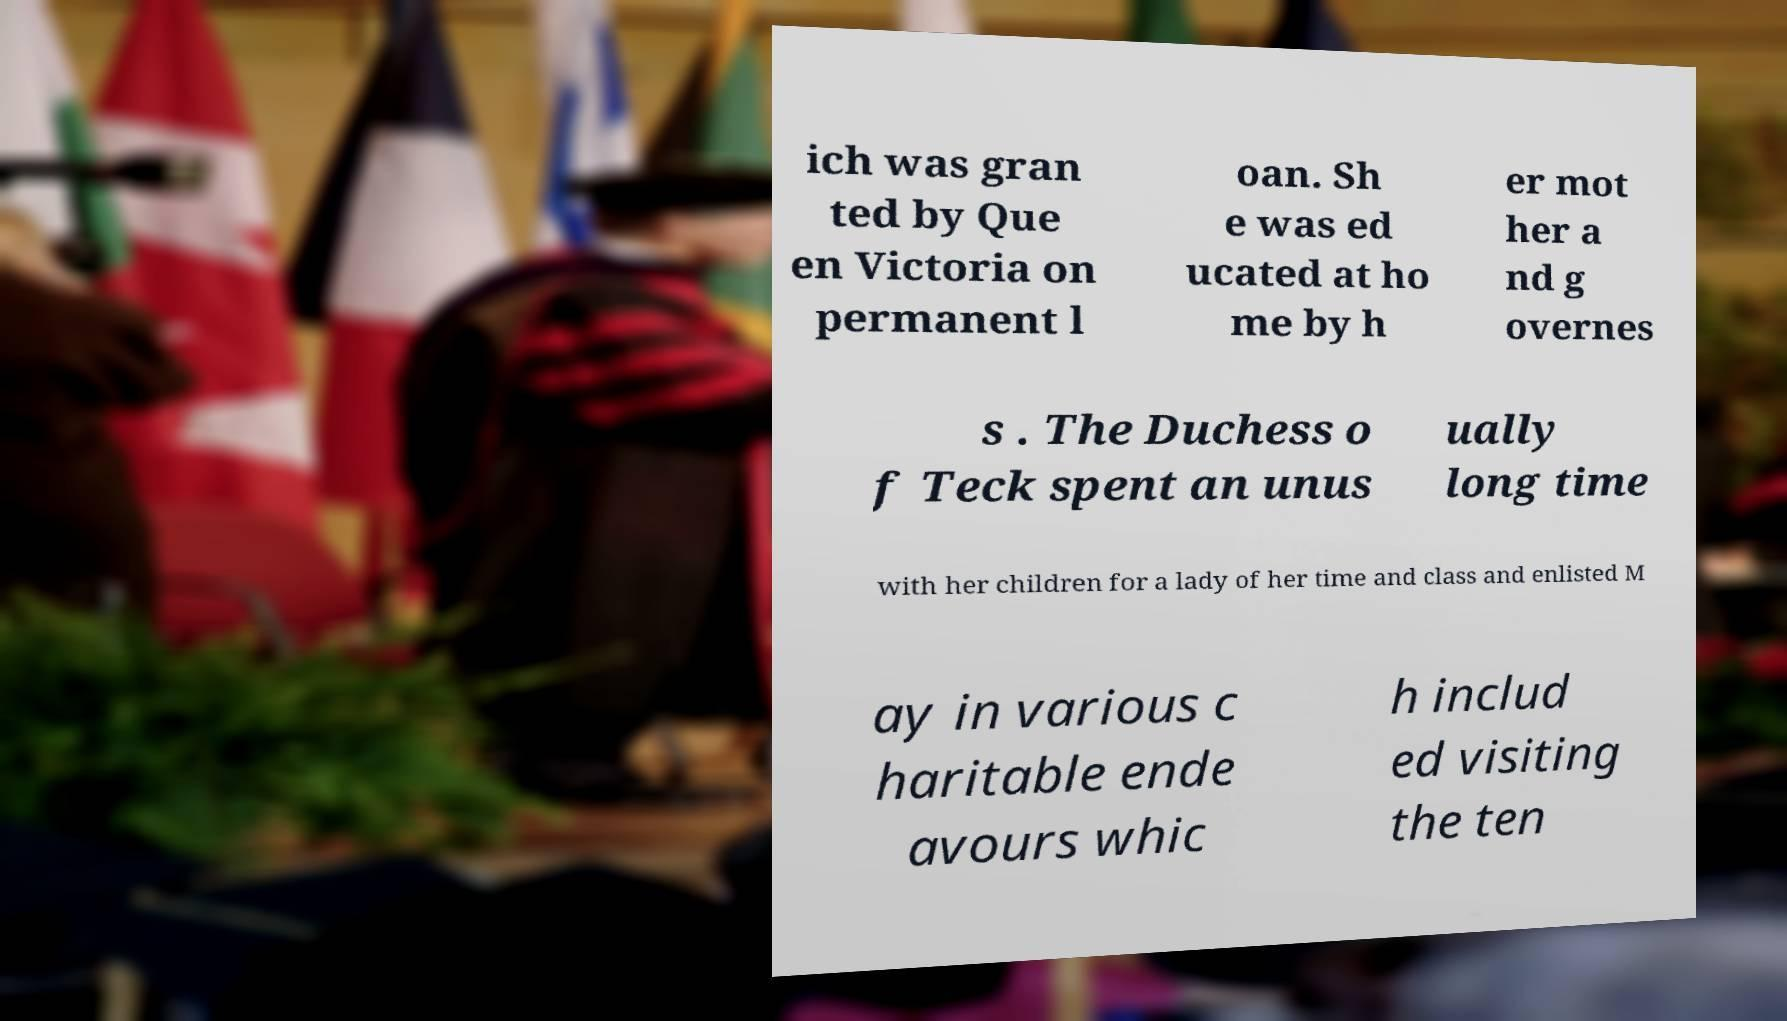For documentation purposes, I need the text within this image transcribed. Could you provide that? ich was gran ted by Que en Victoria on permanent l oan. Sh e was ed ucated at ho me by h er mot her a nd g overnes s . The Duchess o f Teck spent an unus ually long time with her children for a lady of her time and class and enlisted M ay in various c haritable ende avours whic h includ ed visiting the ten 